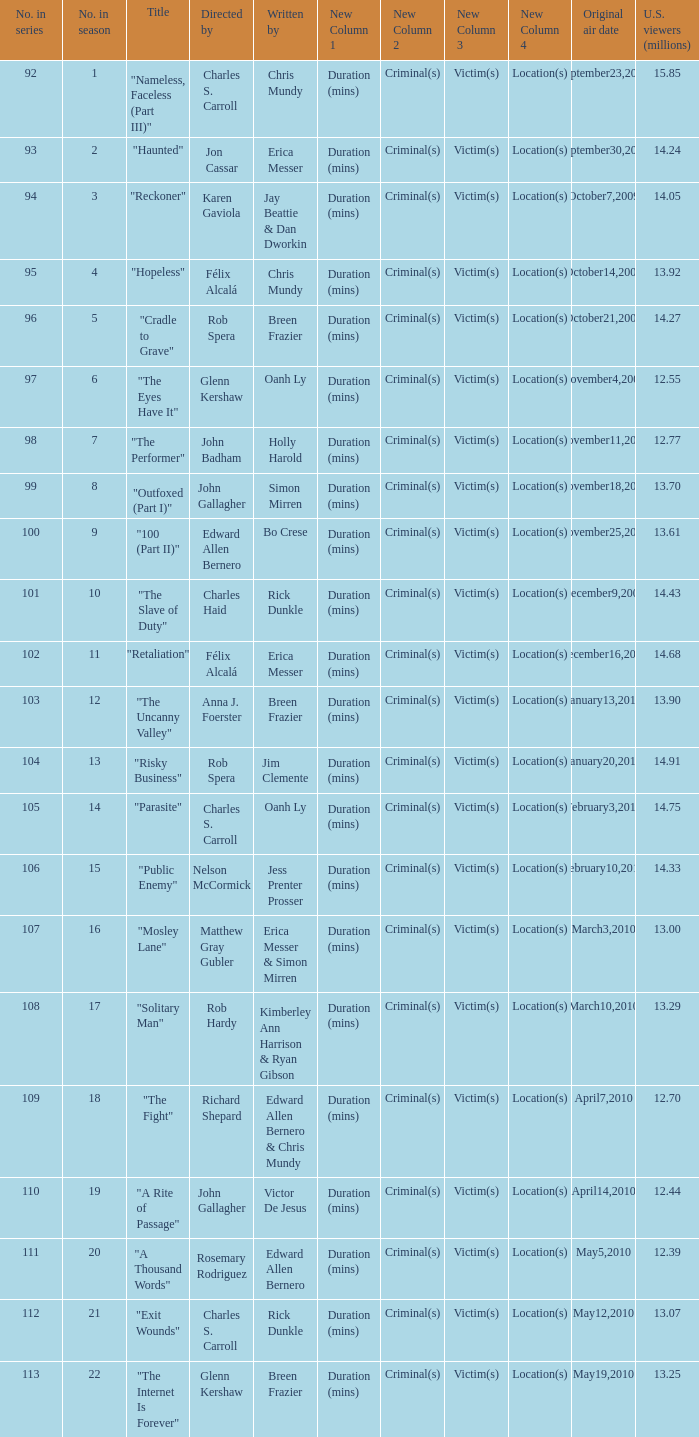Who wrote episode number 109 in the series? Edward Allen Bernero & Chris Mundy. 